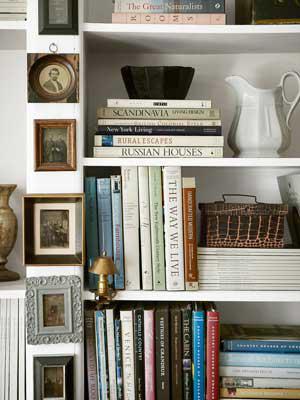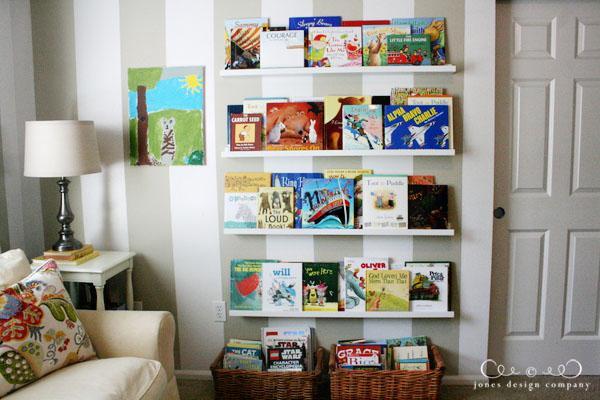The first image is the image on the left, the second image is the image on the right. For the images shown, is this caption "An image includes at least one dark bookcase." true? Answer yes or no. No. The first image is the image on the left, the second image is the image on the right. Assess this claim about the two images: "In one image, at least one lamp and seating are next to a shelving unit.". Correct or not? Answer yes or no. Yes. 